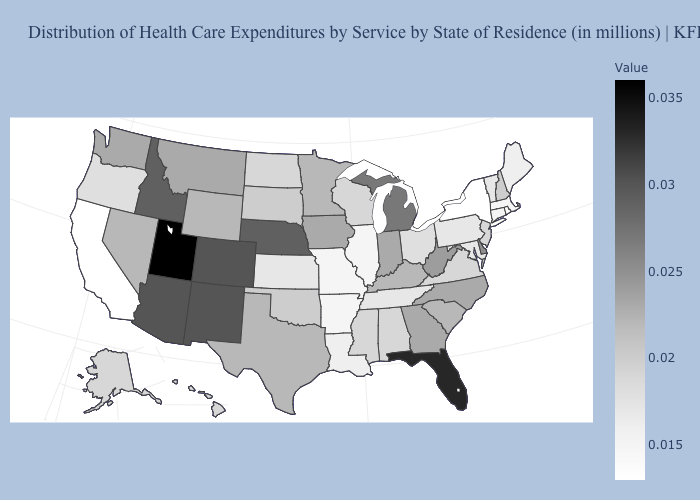Among the states that border New Jersey , which have the highest value?
Concise answer only. Delaware. Among the states that border Florida , which have the highest value?
Quick response, please. Georgia. 